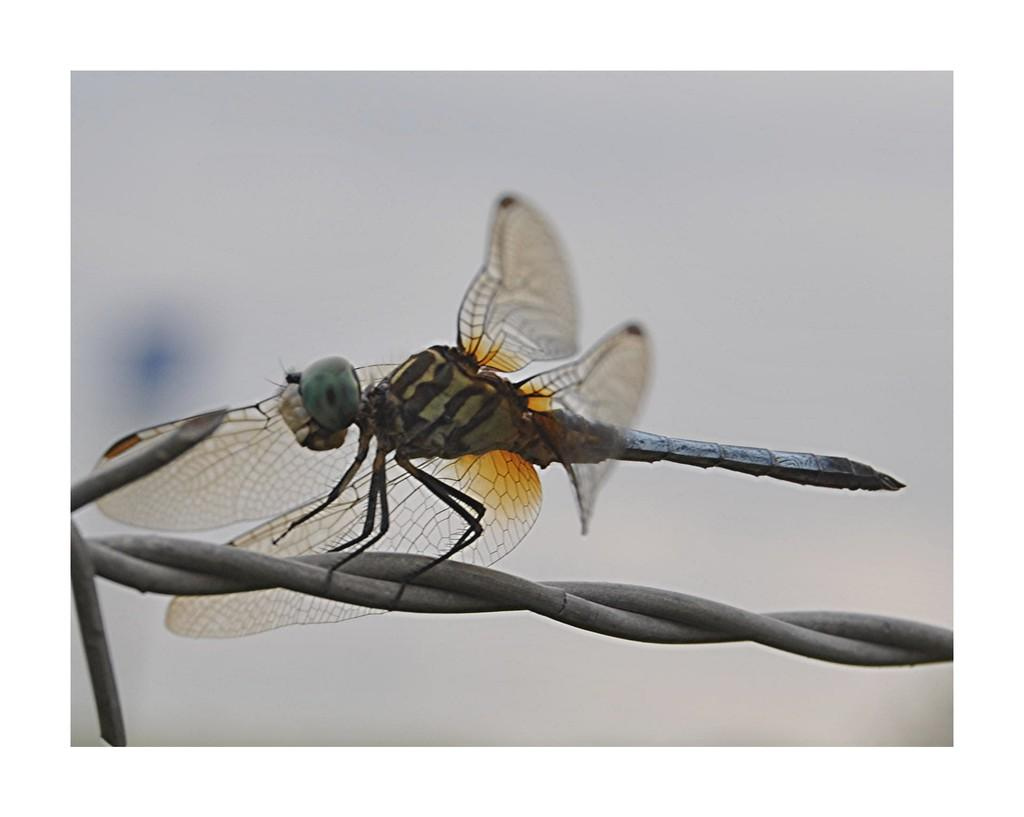What is the main subject of the image? There is a dragonfly in the image. Where is the dragonfly located? The dragonfly is on an iron cable. Can you describe the background of the image? The background of the image is blurred. What note is the dragonfly playing on the iron cable in the image? There is no indication in the image that the dragonfly is playing a note or any musical instrument. 